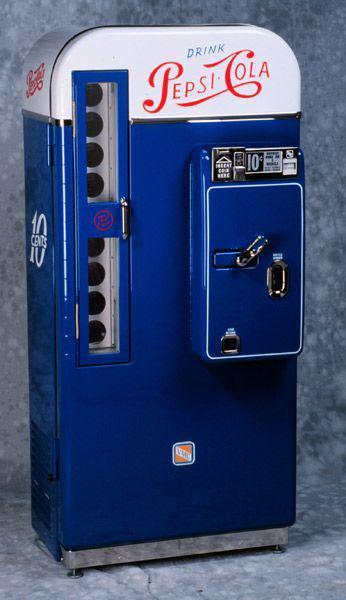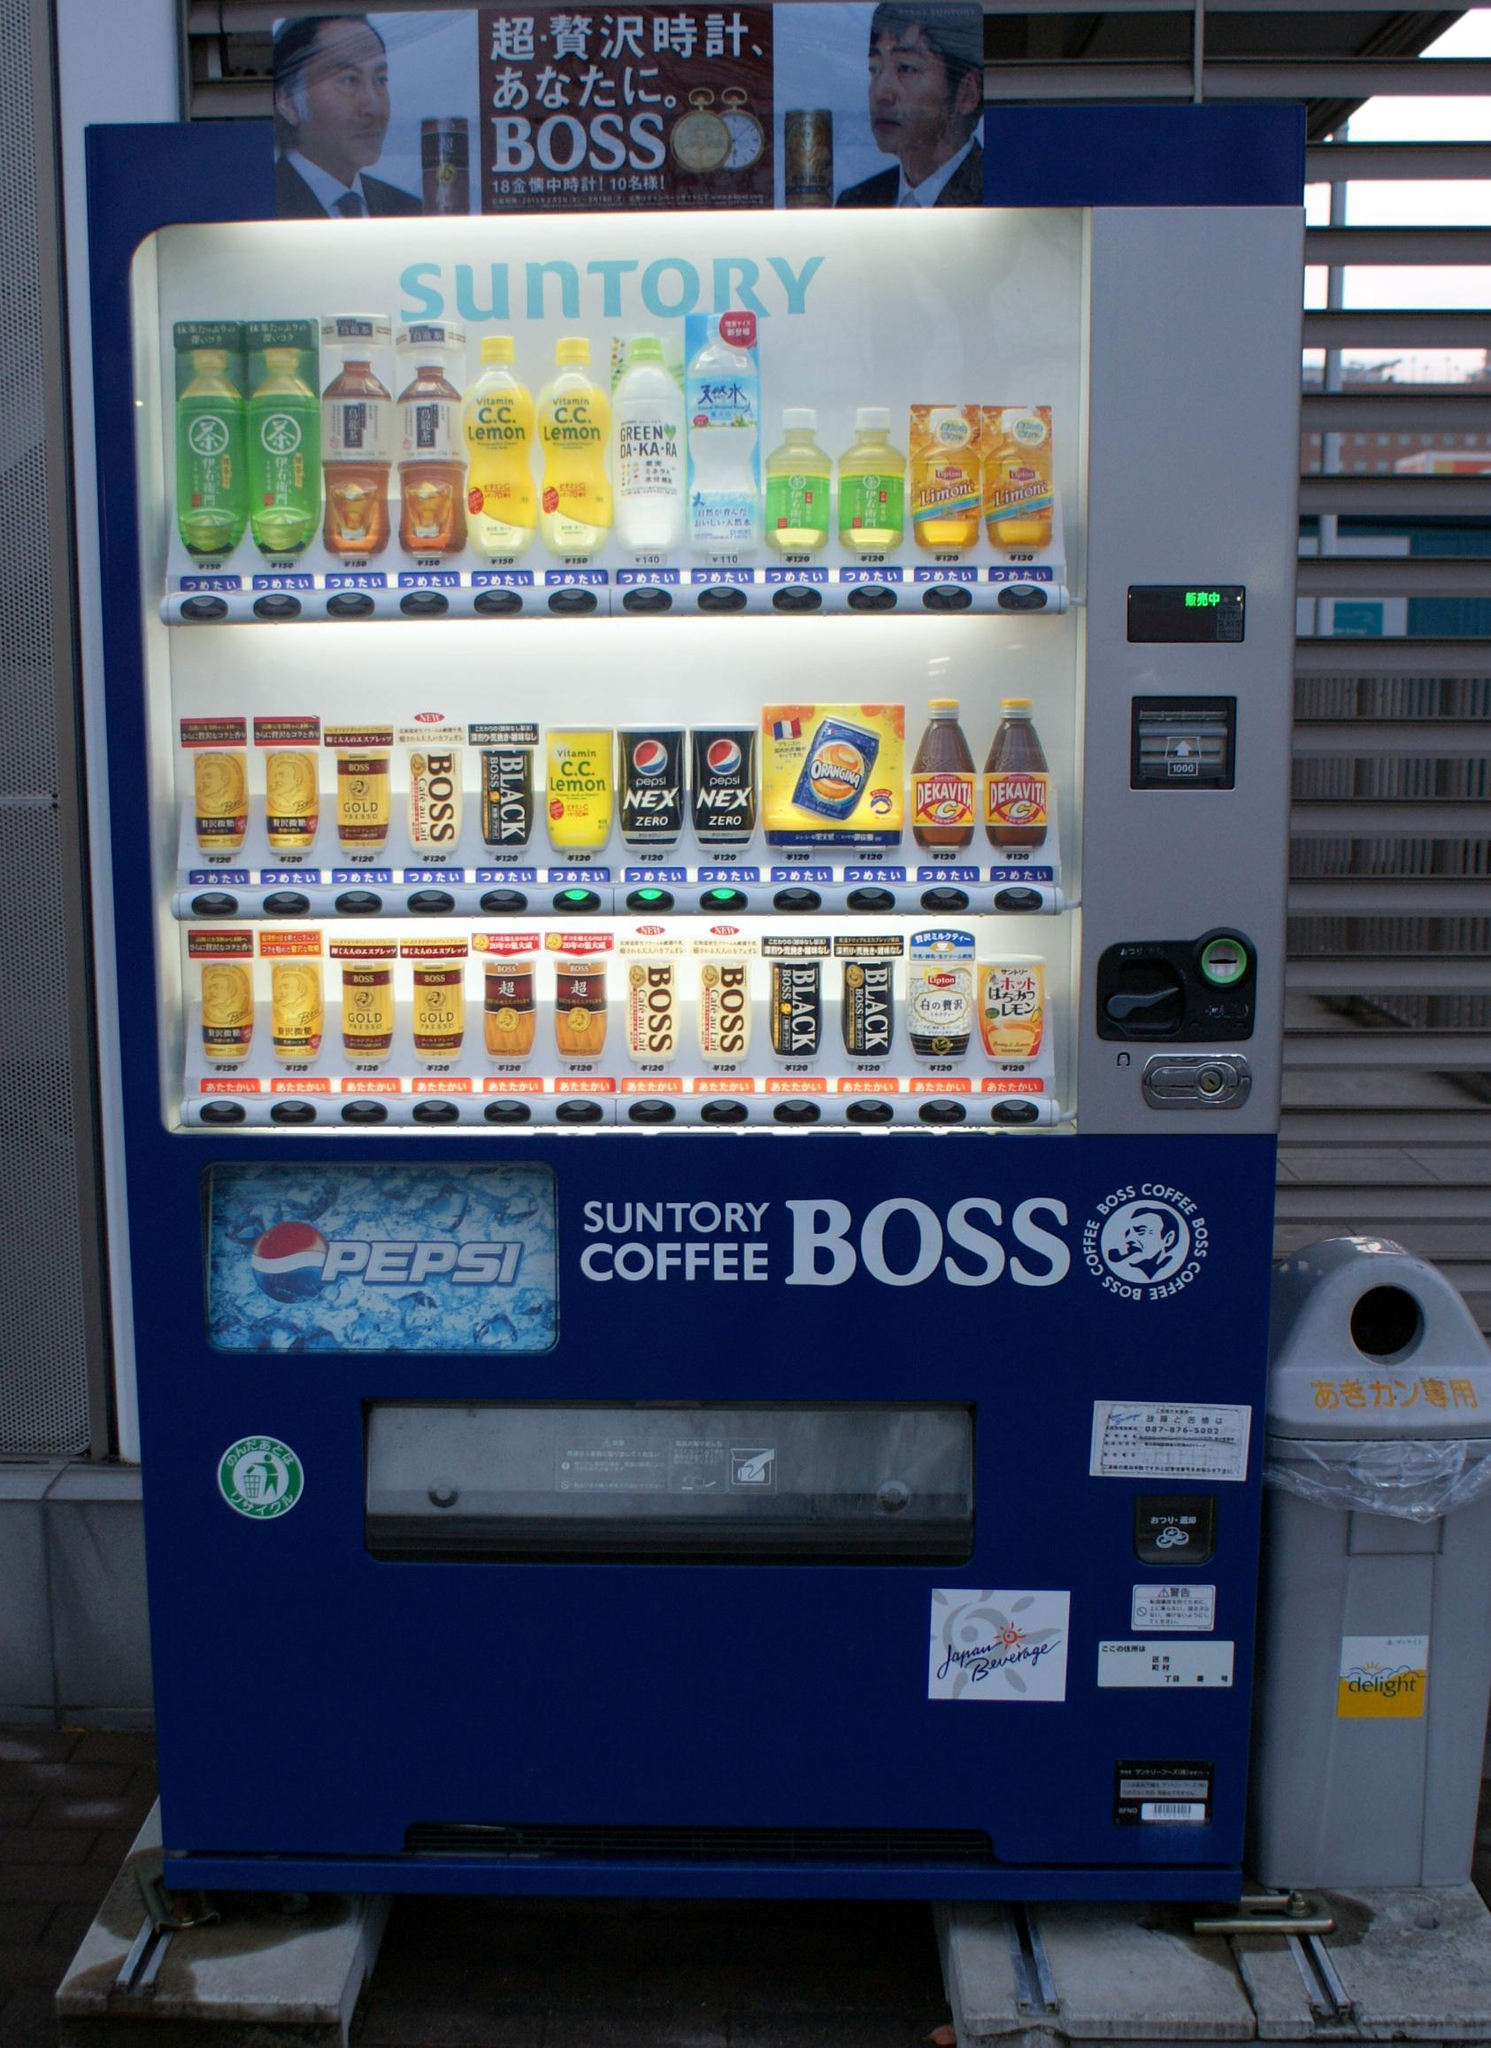The first image is the image on the left, the second image is the image on the right. For the images displayed, is the sentence "There are more machines in the image on the right than in the image on the left." factually correct? Answer yes or no. No. The first image is the image on the left, the second image is the image on the right. Considering the images on both sides, is "Each image prominently features exactly one vending machine, which is blue." valid? Answer yes or no. Yes. 